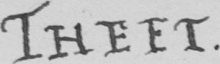Can you tell me what this handwritten text says? THEFT . 